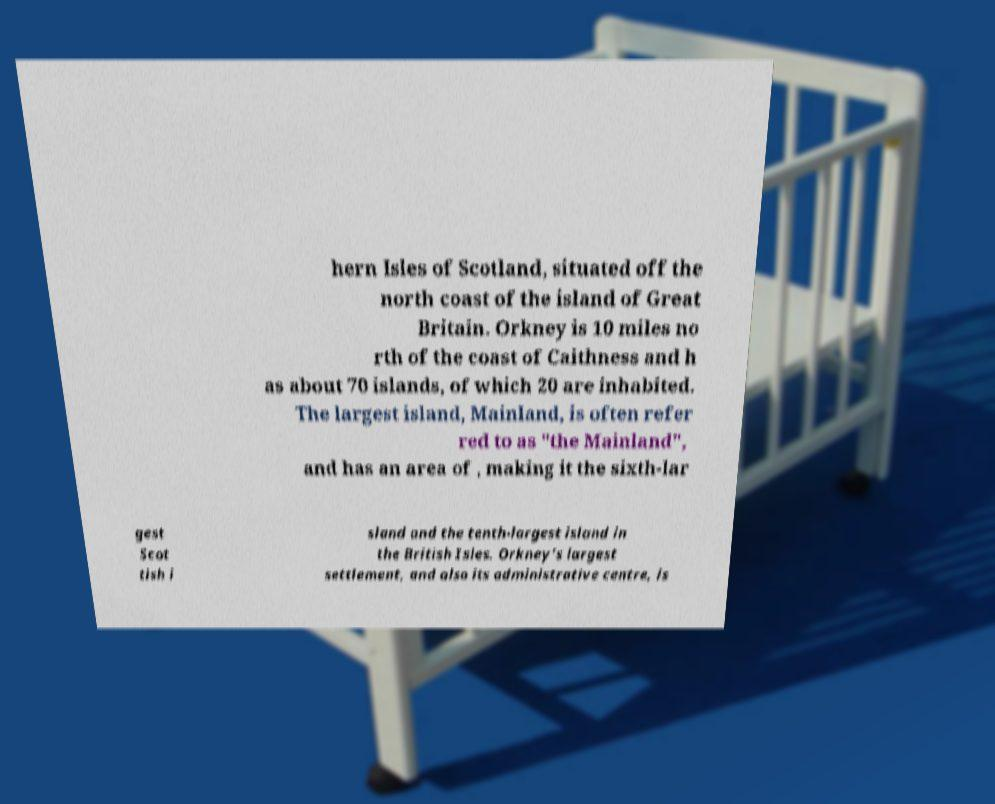Could you assist in decoding the text presented in this image and type it out clearly? hern Isles of Scotland, situated off the north coast of the island of Great Britain. Orkney is 10 miles no rth of the coast of Caithness and h as about 70 islands, of which 20 are inhabited. The largest island, Mainland, is often refer red to as "the Mainland", and has an area of , making it the sixth-lar gest Scot tish i sland and the tenth-largest island in the British Isles. Orkney’s largest settlement, and also its administrative centre, is 